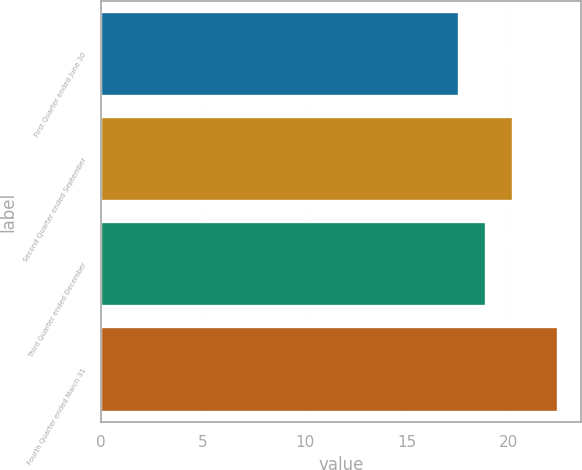<chart> <loc_0><loc_0><loc_500><loc_500><bar_chart><fcel>First Quarter ended June 30<fcel>Second Quarter ended September<fcel>Third Quarter ended December<fcel>Fourth Quarter ended March 31<nl><fcel>17.54<fcel>20.2<fcel>18.87<fcel>22.41<nl></chart> 